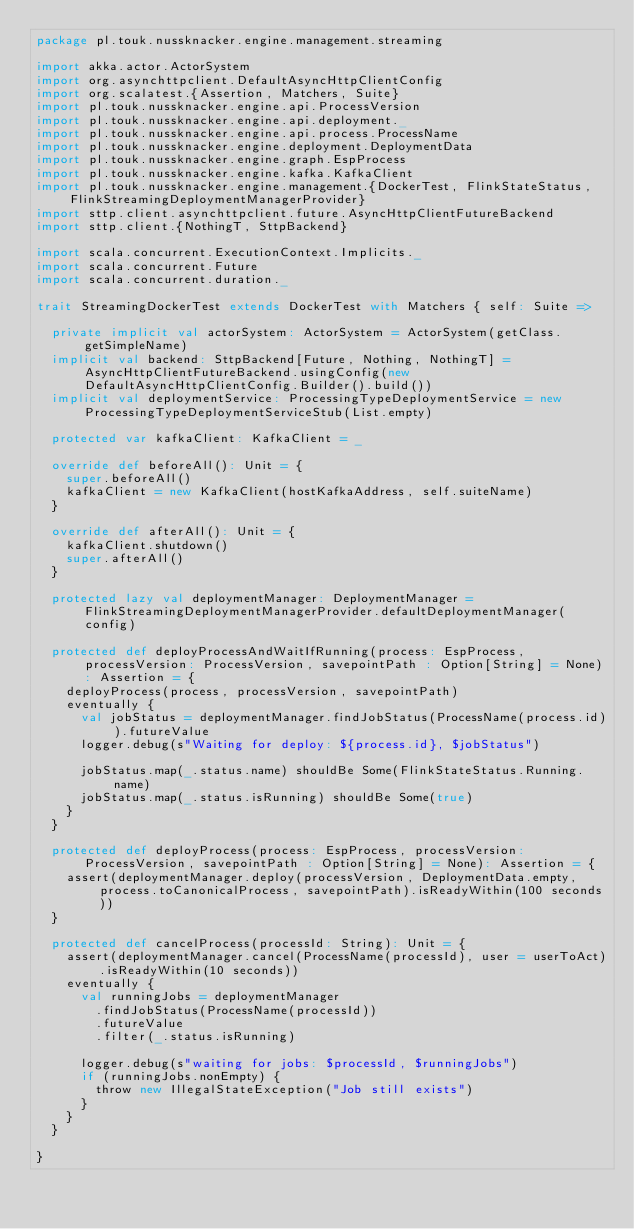Convert code to text. <code><loc_0><loc_0><loc_500><loc_500><_Scala_>package pl.touk.nussknacker.engine.management.streaming

import akka.actor.ActorSystem
import org.asynchttpclient.DefaultAsyncHttpClientConfig
import org.scalatest.{Assertion, Matchers, Suite}
import pl.touk.nussknacker.engine.api.ProcessVersion
import pl.touk.nussknacker.engine.api.deployment._
import pl.touk.nussknacker.engine.api.process.ProcessName
import pl.touk.nussknacker.engine.deployment.DeploymentData
import pl.touk.nussknacker.engine.graph.EspProcess
import pl.touk.nussknacker.engine.kafka.KafkaClient
import pl.touk.nussknacker.engine.management.{DockerTest, FlinkStateStatus, FlinkStreamingDeploymentManagerProvider}
import sttp.client.asynchttpclient.future.AsyncHttpClientFutureBackend
import sttp.client.{NothingT, SttpBackend}

import scala.concurrent.ExecutionContext.Implicits._
import scala.concurrent.Future
import scala.concurrent.duration._

trait StreamingDockerTest extends DockerTest with Matchers { self: Suite =>

  private implicit val actorSystem: ActorSystem = ActorSystem(getClass.getSimpleName)
  implicit val backend: SttpBackend[Future, Nothing, NothingT] = AsyncHttpClientFutureBackend.usingConfig(new DefaultAsyncHttpClientConfig.Builder().build())
  implicit val deploymentService: ProcessingTypeDeploymentService = new ProcessingTypeDeploymentServiceStub(List.empty)

  protected var kafkaClient: KafkaClient = _

  override def beforeAll(): Unit = {
    super.beforeAll()
    kafkaClient = new KafkaClient(hostKafkaAddress, self.suiteName)
  }

  override def afterAll(): Unit = {
    kafkaClient.shutdown()
    super.afterAll()
  }

  protected lazy val deploymentManager: DeploymentManager = FlinkStreamingDeploymentManagerProvider.defaultDeploymentManager(config)

  protected def deployProcessAndWaitIfRunning(process: EspProcess, processVersion: ProcessVersion, savepointPath : Option[String] = None): Assertion = {
    deployProcess(process, processVersion, savepointPath)
    eventually {
      val jobStatus = deploymentManager.findJobStatus(ProcessName(process.id)).futureValue
      logger.debug(s"Waiting for deploy: ${process.id}, $jobStatus")

      jobStatus.map(_.status.name) shouldBe Some(FlinkStateStatus.Running.name)
      jobStatus.map(_.status.isRunning) shouldBe Some(true)
    }
  }

  protected def deployProcess(process: EspProcess, processVersion: ProcessVersion, savepointPath : Option[String] = None): Assertion = {
    assert(deploymentManager.deploy(processVersion, DeploymentData.empty, process.toCanonicalProcess, savepointPath).isReadyWithin(100 seconds))
  }

  protected def cancelProcess(processId: String): Unit = {
    assert(deploymentManager.cancel(ProcessName(processId), user = userToAct).isReadyWithin(10 seconds))
    eventually {
      val runningJobs = deploymentManager
        .findJobStatus(ProcessName(processId))
        .futureValue
        .filter(_.status.isRunning)

      logger.debug(s"waiting for jobs: $processId, $runningJobs")
      if (runningJobs.nonEmpty) {
        throw new IllegalStateException("Job still exists")
      }
    }
  }

}
</code> 